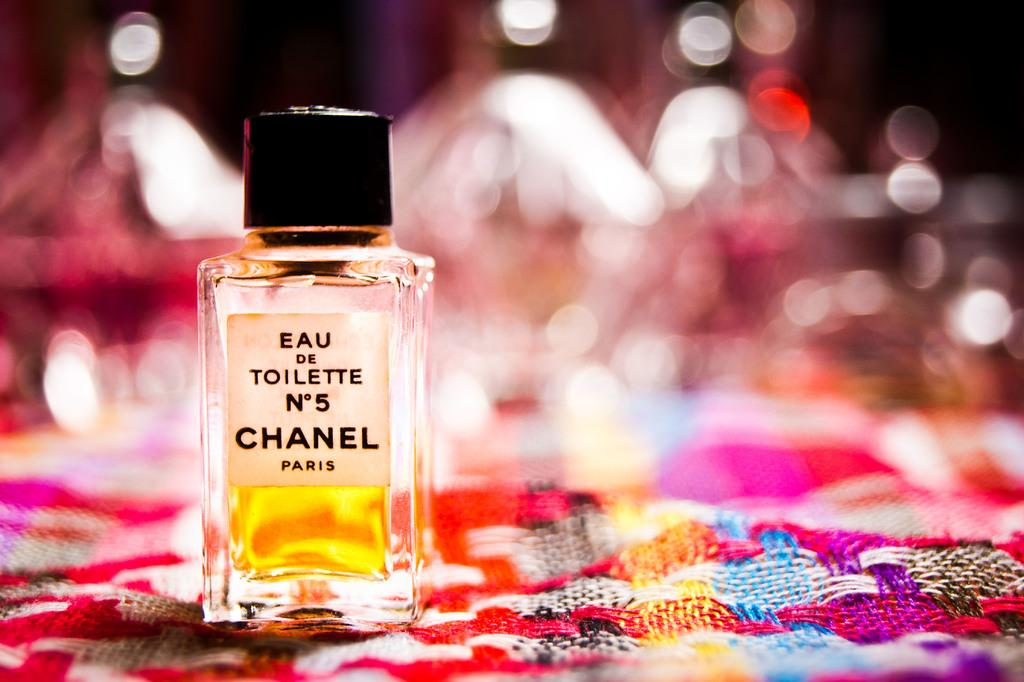Provide a one-sentence caption for the provided image. A bottle of EAU on Toilette Number 5 Chanel Paris. 